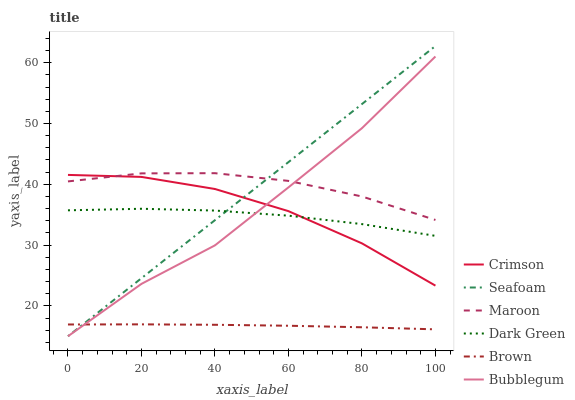Does Brown have the minimum area under the curve?
Answer yes or no. Yes. Does Maroon have the maximum area under the curve?
Answer yes or no. Yes. Does Seafoam have the minimum area under the curve?
Answer yes or no. No. Does Seafoam have the maximum area under the curve?
Answer yes or no. No. Is Seafoam the smoothest?
Answer yes or no. Yes. Is Bubblegum the roughest?
Answer yes or no. Yes. Is Bubblegum the smoothest?
Answer yes or no. No. Is Seafoam the roughest?
Answer yes or no. No. Does Maroon have the lowest value?
Answer yes or no. No. Does Bubblegum have the highest value?
Answer yes or no. No. Is Brown less than Crimson?
Answer yes or no. Yes. Is Maroon greater than Dark Green?
Answer yes or no. Yes. Does Brown intersect Crimson?
Answer yes or no. No. 